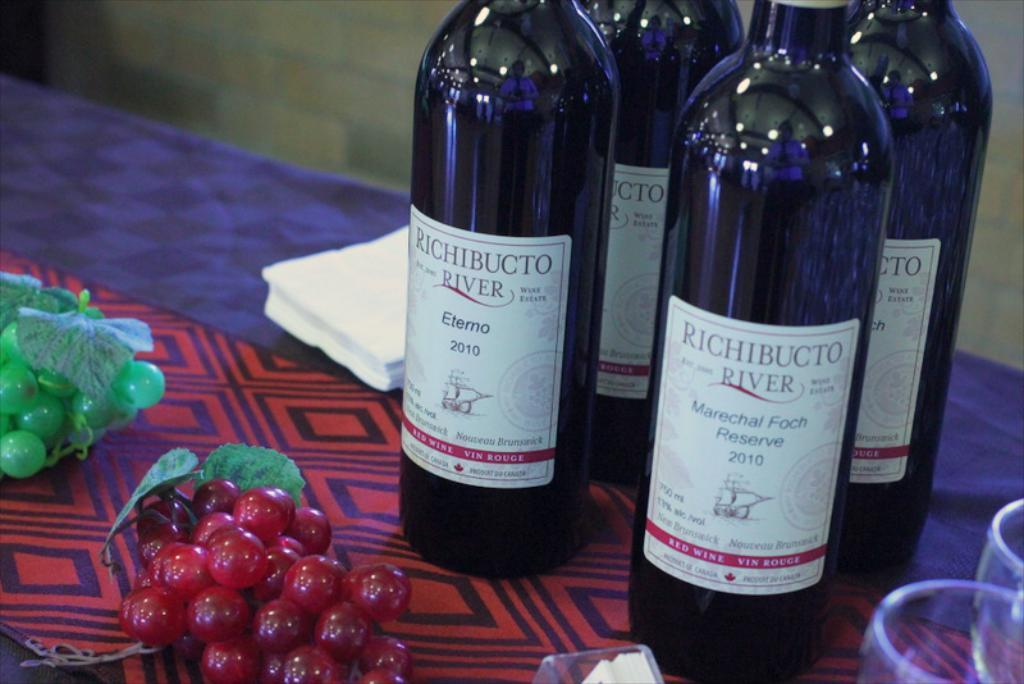<image>
Create a compact narrative representing the image presented. Bottles of Richibucto River wine on a table. 